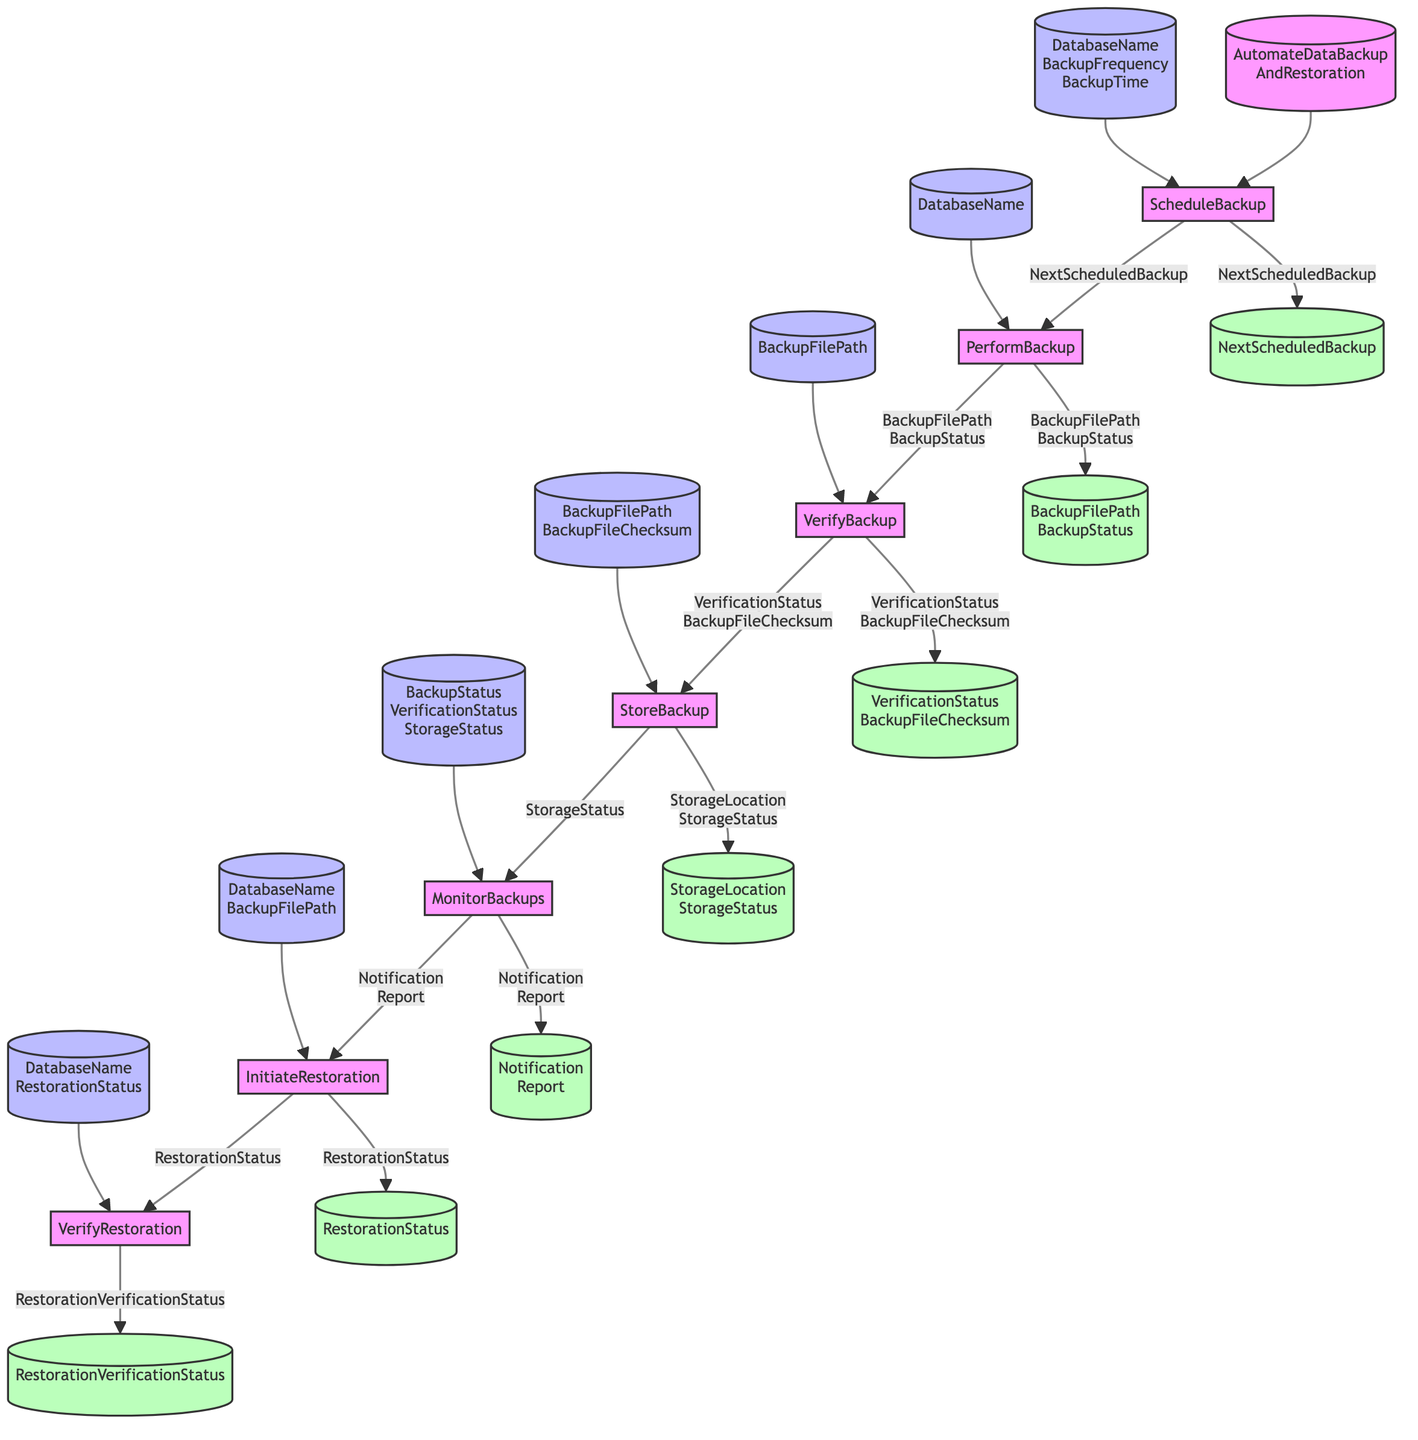What is the first step in the function? The first step in the function, as indicated by the flowchart, is "ScheduleBackup." This is clearly shown as the first node leading from the main function node.
Answer: ScheduleBackup How many total elements are present in the diagram? The diagram contains seven distinct steps, which are illustrated as nodes connected by arrows, representing the complete workflow.
Answer: Seven What inputs are required for the "PerformBackup" step? The "PerformBackup" step requires two inputs: "DatabaseName" and "NextScheduledBackup," which are indicated by the input nodes pointing to this step.
Answer: DatabaseName, NextScheduledBackup What output is generated by the "VerifyBackup" step? The "VerifyBackup" step produces two outputs: "VerificationStatus" and "BackupFileChecksum." This is indicated by the output nodes connected to this step in the flowchart.
Answer: VerificationStatus, BackupFileChecksum Which step comes after "MonitorBackups"? Following the "MonitorBackups" step, the next step indicated in the flowchart is "InitiateRestoration," which is the immediate step in the sequence of processes.
Answer: InitiateRestoration What does the "StoreBackup" step require as inputs? The "StoreBackup" step takes two inputs: "BackupFilePath" and "BackupFileChecksum," as specified by the input node leading to this step.
Answer: BackupFilePath, BackupFileChecksum How is the connection between "PerformBackup" and "VerifyBackup" described in the diagram? The connection between "PerformBackup" and "VerifyBackup" is represented by an output in the "PerformBackup" step, leading with the combined output "BackupFilePath" and "BackupStatus," demonstrating the flow of information.
Answer: BackupFilePath, BackupStatus What is the last step performed in the workflow? The last step in the workflow, as depicted in the flowchart, is "VerifyRestoration," which follows the "InitiateRestoration" step in the sequence.
Answer: VerifyRestoration What type of status does the "MonitorBackups" step generate? The "MonitorBackups" step generates two types of statuses: "Notification" and "Report," which are outputs shown connected to this step in the diagram.
Answer: Notification, Report 